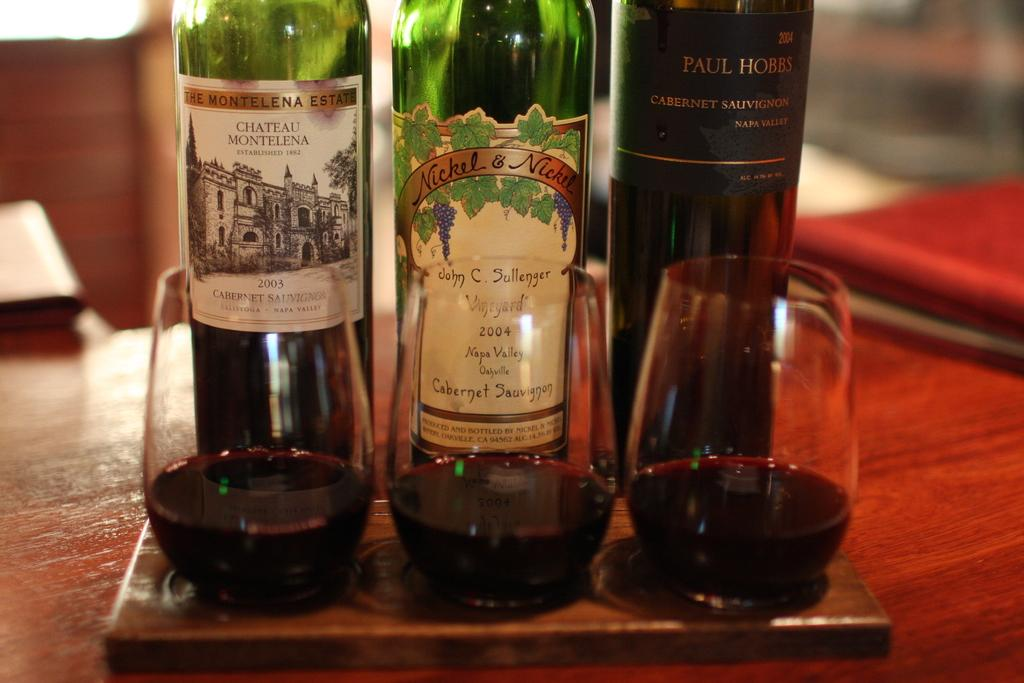Provide a one-sentence caption for the provided image. Wine bottle from the year 2004 behind three cups. 